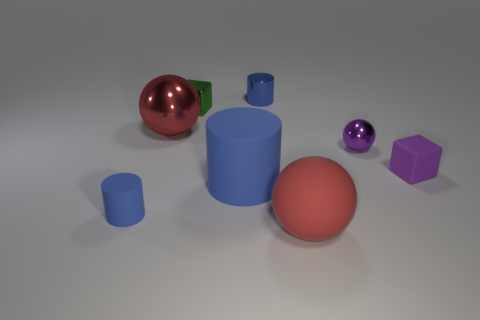There is a cube on the right side of the small blue shiny cylinder; does it have the same size as the ball on the left side of the large red matte object?
Offer a very short reply. No. Are there more large matte objects behind the tiny rubber cylinder than large red things that are right of the green block?
Your answer should be compact. No. What number of tiny purple matte objects are the same shape as the green shiny thing?
Give a very brief answer. 1. What is the material of the green cube that is the same size as the purple sphere?
Your answer should be compact. Metal. Are there any large cyan spheres made of the same material as the big blue thing?
Offer a very short reply. No. Is the number of red objects in front of the red rubber thing less than the number of purple matte blocks?
Keep it short and to the point. Yes. There is a red sphere that is behind the tiny rubber thing that is left of the matte sphere; what is its material?
Provide a succinct answer. Metal. There is a object that is right of the small metal cylinder and in front of the large rubber cylinder; what shape is it?
Offer a terse response. Sphere. How many other things are there of the same color as the big rubber ball?
Your response must be concise. 1. What number of objects are tiny things that are to the right of the small green object or blue rubber cylinders?
Offer a very short reply. 5. 